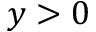<formula> <loc_0><loc_0><loc_500><loc_500>y > 0</formula> 